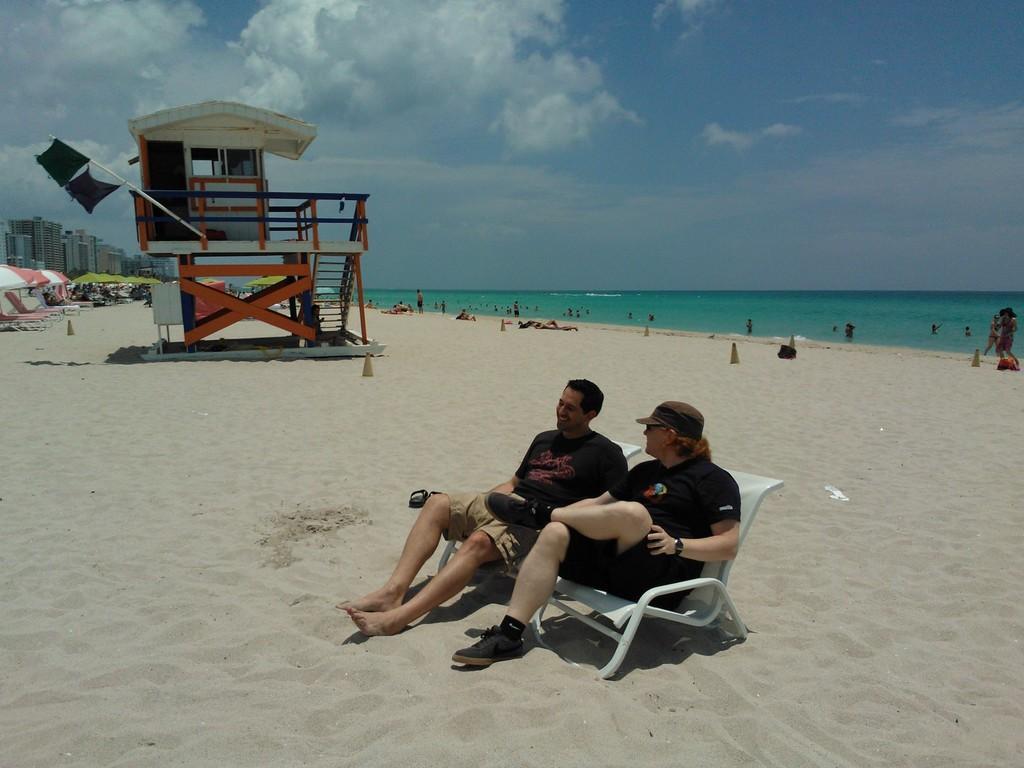Could you give a brief overview of what you see in this image? This image is clicked at a beach. In the foreground there are people sitting on a bench. Behind them there is a house. To the right there is the water. There are people on the shore. To the left there table umbrellas and chairs. In the background there are buildings. At the top there is the sky. 